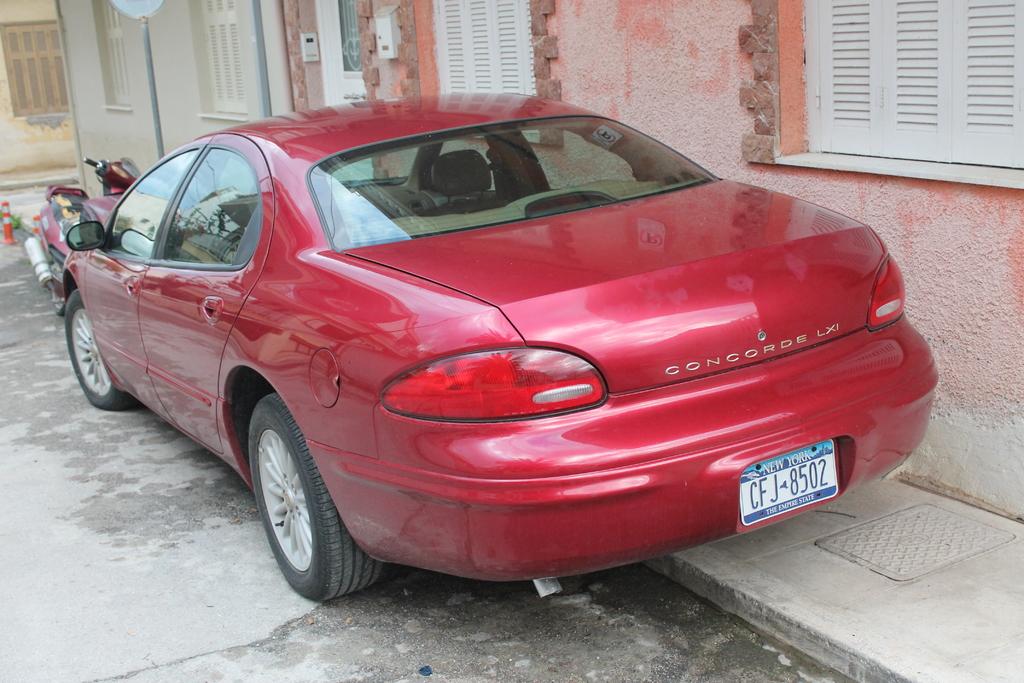What is the licence plate of the car?
Your response must be concise. Cfj 8502. What type of car is this?
Provide a succinct answer. Concorde lxi. 